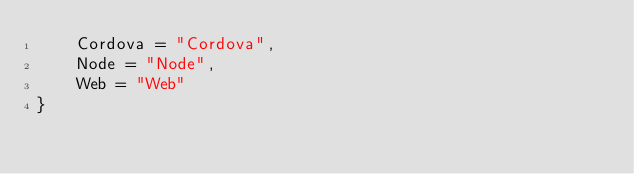Convert code to text. <code><loc_0><loc_0><loc_500><loc_500><_TypeScript_>    Cordova = "Cordova",
    Node = "Node",
    Web = "Web"
}
</code> 